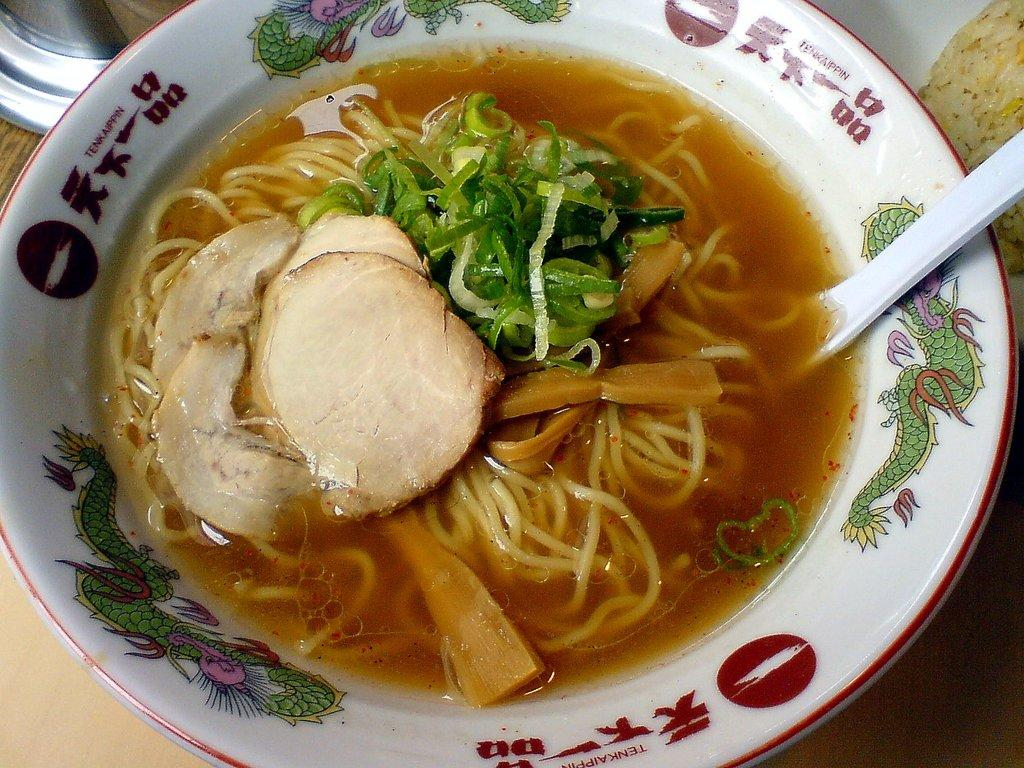What is the main subject of the image? There is a food item in the image. How is the food item presented in the image? The food item is in a bowl. What utensil is visible in the image? There is a spoon in the image. What type of company is mentioned in the list of ingredients for the food item in the image? There is no list of ingredients or company mentioned in the image; it only shows a food item in a bowl with a spoon. 